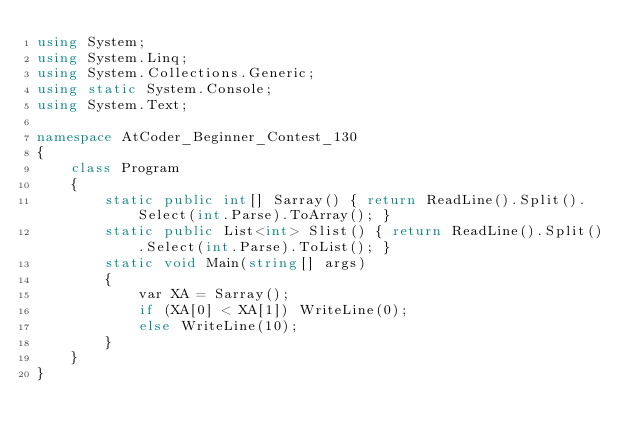<code> <loc_0><loc_0><loc_500><loc_500><_C#_>using System;
using System.Linq;
using System.Collections.Generic;
using static System.Console;
using System.Text;

namespace AtCoder_Beginner_Contest_130
{
    class Program
    {
        static public int[] Sarray() { return ReadLine().Split().Select(int.Parse).ToArray(); }
        static public List<int> Slist() { return ReadLine().Split().Select(int.Parse).ToList(); }
        static void Main(string[] args)
        {
            var XA = Sarray();
            if (XA[0] < XA[1]) WriteLine(0);
            else WriteLine(10);
        }
    }
}</code> 